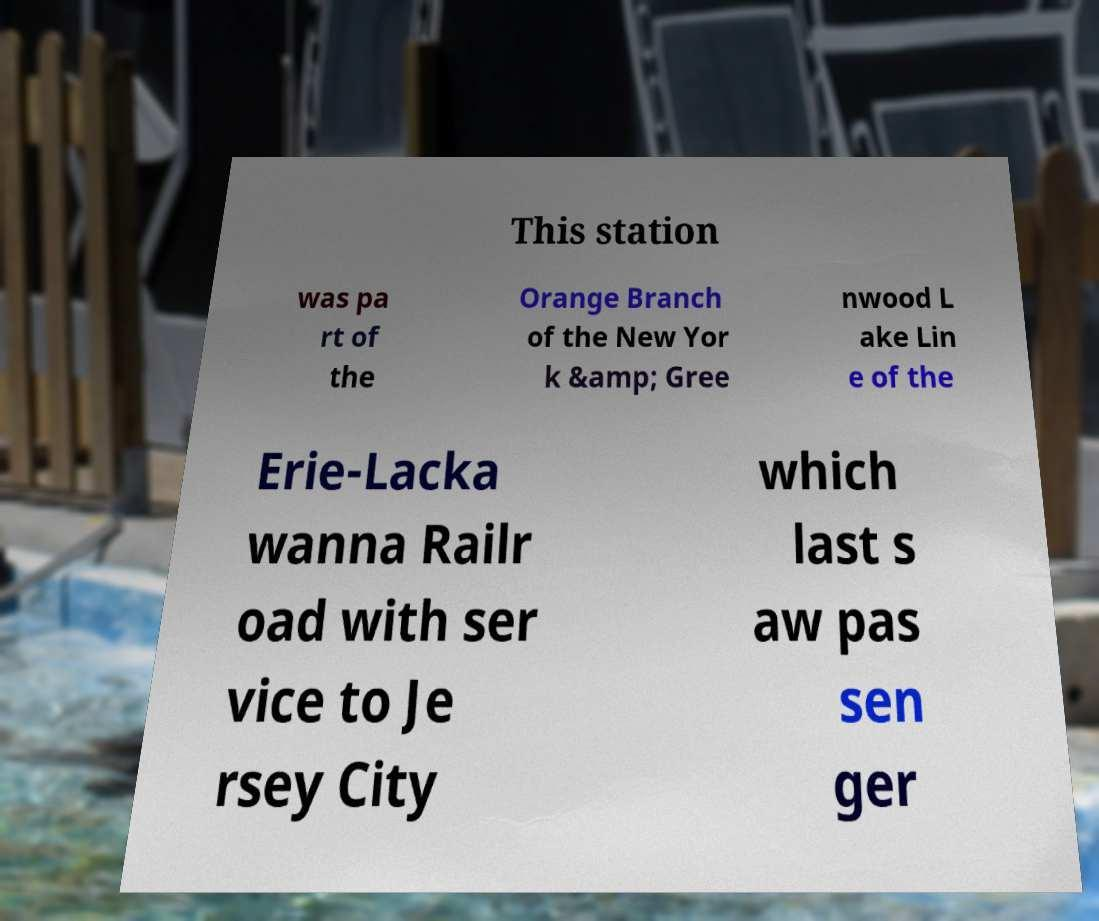There's text embedded in this image that I need extracted. Can you transcribe it verbatim? This station was pa rt of the Orange Branch of the New Yor k &amp; Gree nwood L ake Lin e of the Erie-Lacka wanna Railr oad with ser vice to Je rsey City which last s aw pas sen ger 